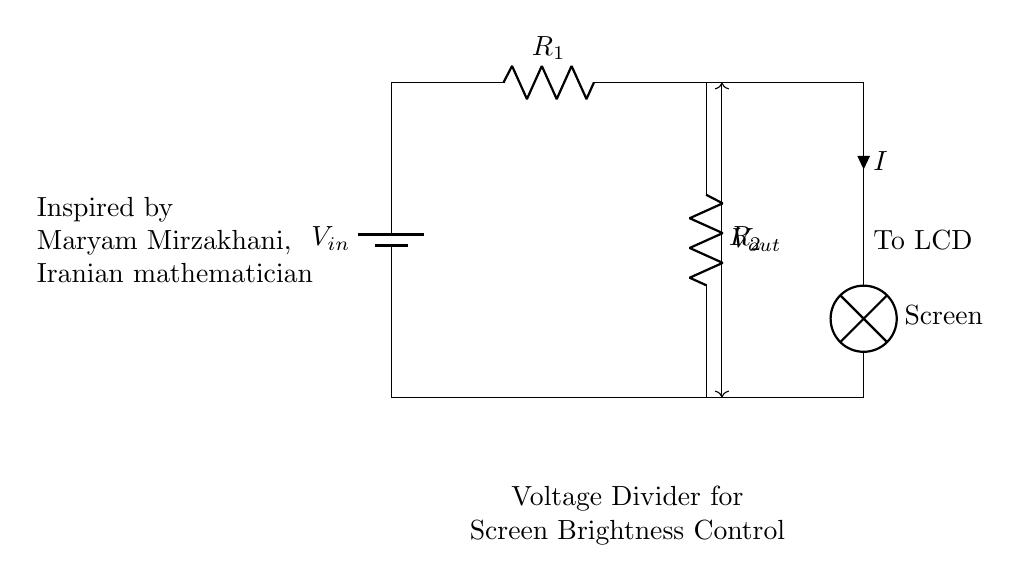What is the input voltage of this circuit? The input voltage is represented as \( V_{in} \), which is indicated at the top of the circuit diagram connected to the battery.
Answer: \( V_{in} \) What are the resistors' values in the circuit? The resistors are labeled as \( R_1 \) and \( R_2 \) in the circuit diagram, but their specific values are not detailed. They are identified by their labels.
Answer: \( R_1 \) and \( R_2 \) What does the arrow on \( V_{out} \) indicate? The arrow on \( V_{out} \) denotes the output voltage across the resistors \( R_1 \) and \( R_2 \) and shows how it is dropped for the screen brightness control.
Answer: Output voltage What happens to the current going through the circuit? The current \( I \) flows from the battery through \( R_1 \), then \( R_2 \), and finally to the LCD screen, indicating a series circuit configuration.
Answer: Flows to LCD Why is a voltage divider used in mobile devices? A voltage divider is used to reduce the voltage to a desired level that is suitable for controlling the brightness of the mobile device's screen, providing better power management.
Answer: To adjust screen brightness What does the screen represent in this circuit? The screen represents the load or output device that receives the adjusted voltage from the voltage divider, specifically for displaying brightness levels to the user.
Answer: Load for brightness Who is mentioned as an inspiration in this circuit diagram? The circuit diagram mentions Maryam Mirzakhani, which suggests an inspirational context linking the circuit's purpose of innovation and women's contributions in history.
Answer: Maryam Mirzakhani 